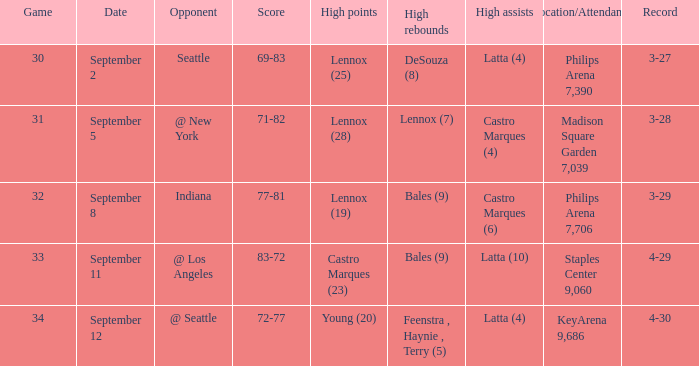What was the Location/Attendance on september 11? Staples Center 9,060. 